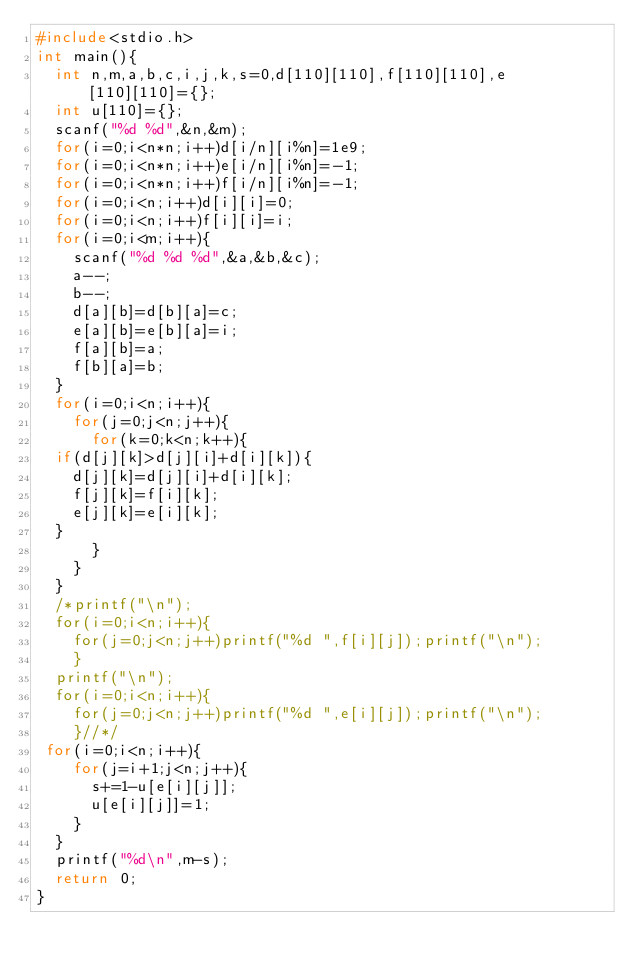Convert code to text. <code><loc_0><loc_0><loc_500><loc_500><_C_>#include<stdio.h>
int main(){
  int n,m,a,b,c,i,j,k,s=0,d[110][110],f[110][110],e[110][110]={};
  int u[110]={};
  scanf("%d %d",&n,&m);
  for(i=0;i<n*n;i++)d[i/n][i%n]=1e9;
  for(i=0;i<n*n;i++)e[i/n][i%n]=-1;
  for(i=0;i<n*n;i++)f[i/n][i%n]=-1;
  for(i=0;i<n;i++)d[i][i]=0;
  for(i=0;i<n;i++)f[i][i]=i;
  for(i=0;i<m;i++){
    scanf("%d %d %d",&a,&b,&c);
    a--;
    b--;
    d[a][b]=d[b][a]=c;
    e[a][b]=e[b][a]=i;
    f[a][b]=a;
    f[b][a]=b;
  }
  for(i=0;i<n;i++){
    for(j=0;j<n;j++){
      for(k=0;k<n;k++){
	if(d[j][k]>d[j][i]+d[i][k]){
	  d[j][k]=d[j][i]+d[i][k];
	  f[j][k]=f[i][k];
	  e[j][k]=e[i][k];
	}
      }
    }
  }
  /*printf("\n");
  for(i=0;i<n;i++){
    for(j=0;j<n;j++)printf("%d ",f[i][j]);printf("\n");
    }
  printf("\n");
  for(i=0;i<n;i++){
    for(j=0;j<n;j++)printf("%d ",e[i][j]);printf("\n");
    }//*/
 for(i=0;i<n;i++){
    for(j=i+1;j<n;j++){
      s+=1-u[e[i][j]];
      u[e[i][j]]=1;
    }
  }
  printf("%d\n",m-s);
  return 0;
}
  
</code> 